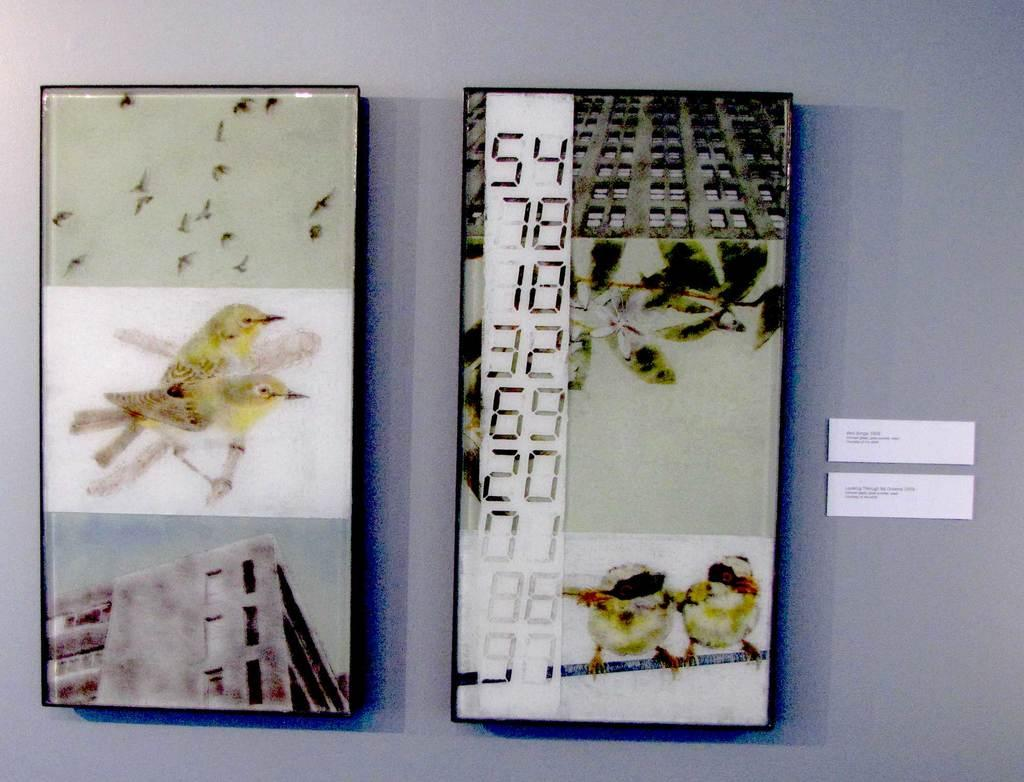What is located on the wall in the foreground of the image? There are two frames on a wall in the foreground of the image. What can be seen on the right side of the image? There are two dialogue boxes on the right side of the image. What type of jam is being spread by the zephyr in the image? There is no jam or zephyr present in the image. What advice does the father give to his child in the image? There is no father or child present in the image, and therefore no conversation or advice can be observed. 